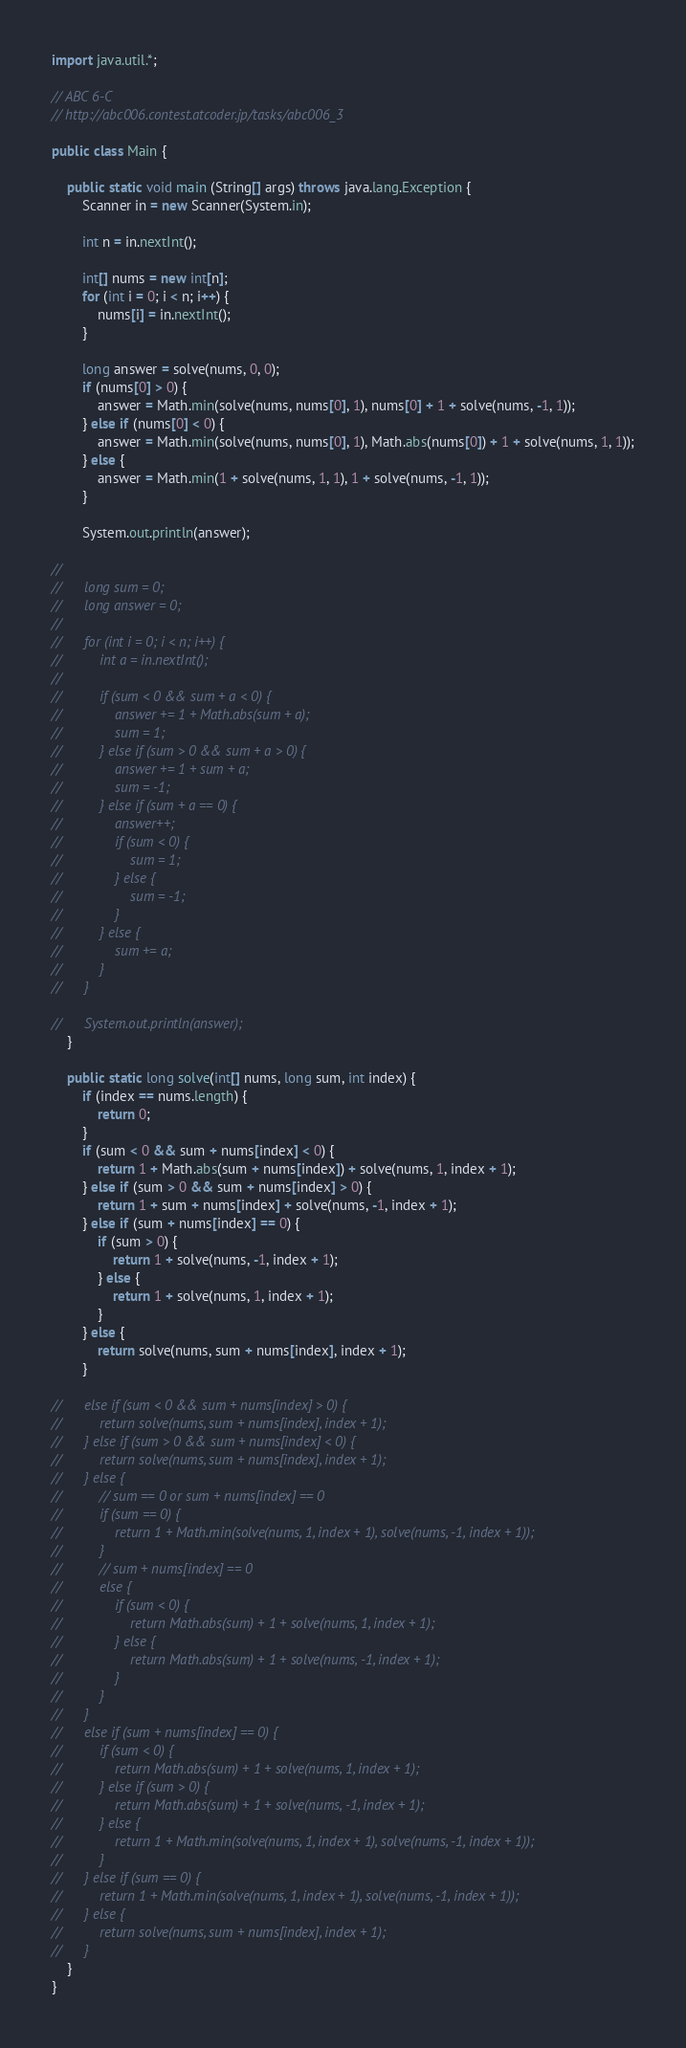<code> <loc_0><loc_0><loc_500><loc_500><_Java_>import java.util.*;

// ABC 6-C
// http://abc006.contest.atcoder.jp/tasks/abc006_3
 
public class Main {
	
	public static void main (String[] args) throws java.lang.Exception {
		Scanner in = new Scanner(System.in);

		int n = in.nextInt();
		
		int[] nums = new int[n];
		for (int i = 0; i < n; i++) {
			nums[i] = in.nextInt();
		}
		
		long answer = solve(nums, 0, 0);
		if (nums[0] > 0) {
			answer = Math.min(solve(nums, nums[0], 1), nums[0] + 1 + solve(nums, -1, 1));
		} else if (nums[0] < 0) {
			answer = Math.min(solve(nums, nums[0], 1), Math.abs(nums[0]) + 1 + solve(nums, 1, 1));
		} else {
			answer = Math.min(1 + solve(nums, 1, 1), 1 + solve(nums, -1, 1));
		}
		
		System.out.println(answer);
		
//		
//		long sum = 0;
//		long answer = 0;
//		
//		for (int i = 0; i < n; i++) {
//			int a = in.nextInt();
//			
//			if (sum < 0 && sum + a < 0) {
//				answer += 1 + Math.abs(sum + a);
//				sum = 1;
//			} else if (sum > 0 && sum + a > 0) {
//				answer += 1 + sum + a;
//				sum = -1;
//			} else if (sum + a == 0) {
//				answer++;
//				if (sum < 0) {
//					sum = 1;
//				} else {
//					sum = -1;
//				}
//			} else { 
//				sum += a;
//			}
//		}
		
//		System.out.println(answer);
	}
	
	public static long solve(int[] nums, long sum, int index) {
		if (index == nums.length) {
			return 0;
		}
		if (sum < 0 && sum + nums[index] < 0) {
			return 1 + Math.abs(sum + nums[index]) + solve(nums, 1, index + 1);
		} else if (sum > 0 && sum + nums[index] > 0) {
			return 1 + sum + nums[index] + solve(nums, -1, index + 1);
		} else if (sum + nums[index] == 0) {
			if (sum > 0) {
				return 1 + solve(nums, -1, index + 1);
			} else {
				return 1 + solve(nums, 1, index + 1);
			}
		} else {
			return solve(nums, sum + nums[index], index + 1);
		}
		
//		else if (sum < 0 && sum + nums[index] > 0) {
//			return solve(nums, sum + nums[index], index + 1);
//		} else if (sum > 0 && sum + nums[index] < 0) {
//			return solve(nums, sum + nums[index], index + 1);
//		} else {
//			// sum == 0 or sum + nums[index] == 0
//			if (sum == 0) {
//				return 1 + Math.min(solve(nums, 1, index + 1), solve(nums, -1, index + 1));
//			}
//			// sum + nums[index] == 0
//			else {
//				if (sum < 0) {
//					return Math.abs(sum) + 1 + solve(nums, 1, index + 1);
//				} else {
//					return Math.abs(sum) + 1 + solve(nums, -1, index + 1);
//				}
//			}
//		} 
//		else if (sum + nums[index] == 0) {
//			if (sum < 0) {
//				return Math.abs(sum) + 1 + solve(nums, 1, index + 1);
//			} else if (sum > 0) {
//				return Math.abs(sum) + 1 + solve(nums, -1, index + 1);
//			} else {
//				return 1 + Math.min(solve(nums, 1, index + 1), solve(nums, -1, index + 1));
//			}
//		} else if (sum == 0) {
//			return 1 + Math.min(solve(nums, 1, index + 1), solve(nums, -1, index + 1));
//		} else {
//			return solve(nums, sum + nums[index], index + 1);
//		}
	}
}</code> 